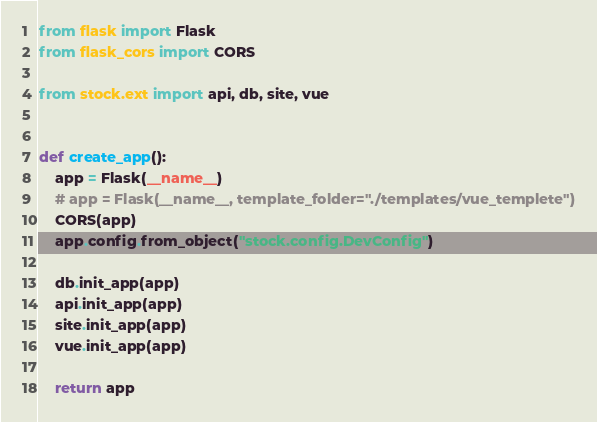<code> <loc_0><loc_0><loc_500><loc_500><_Python_>from flask import Flask
from flask_cors import CORS

from stock.ext import api, db, site, vue


def create_app():
    app = Flask(__name__)
    # app = Flask(__name__, template_folder="./templates/vue_templete")
    CORS(app)
    app.config.from_object("stock.config.DevConfig")

    db.init_app(app)
    api.init_app(app)
    site.init_app(app)
    vue.init_app(app)

    return app
</code> 